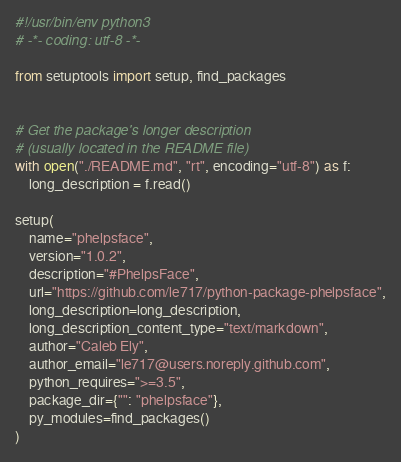Convert code to text. <code><loc_0><loc_0><loc_500><loc_500><_Python_>#!/usr/bin/env python3
# -*- coding: utf-8 -*-

from setuptools import setup, find_packages


# Get the package's longer description
# (usually located in the README file)
with open("./README.md", "rt", encoding="utf-8") as f:
    long_description = f.read()

setup(
    name="phelpsface",
    version="1.0.2",
    description="#PhelpsFace",
    url="https://github.com/le717/python-package-phelpsface",
    long_description=long_description,
    long_description_content_type="text/markdown",
    author="Caleb Ely",
    author_email="le717@users.noreply.github.com",
    python_requires=">=3.5",
    package_dir={"": "phelpsface"},
    py_modules=find_packages()
)
</code> 